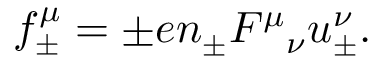Convert formula to latex. <formula><loc_0><loc_0><loc_500><loc_500>f _ { \pm } ^ { \mu } = \pm e n _ { \pm } { F ^ { \mu } } _ { \nu } u _ { \pm } ^ { \nu } .</formula> 